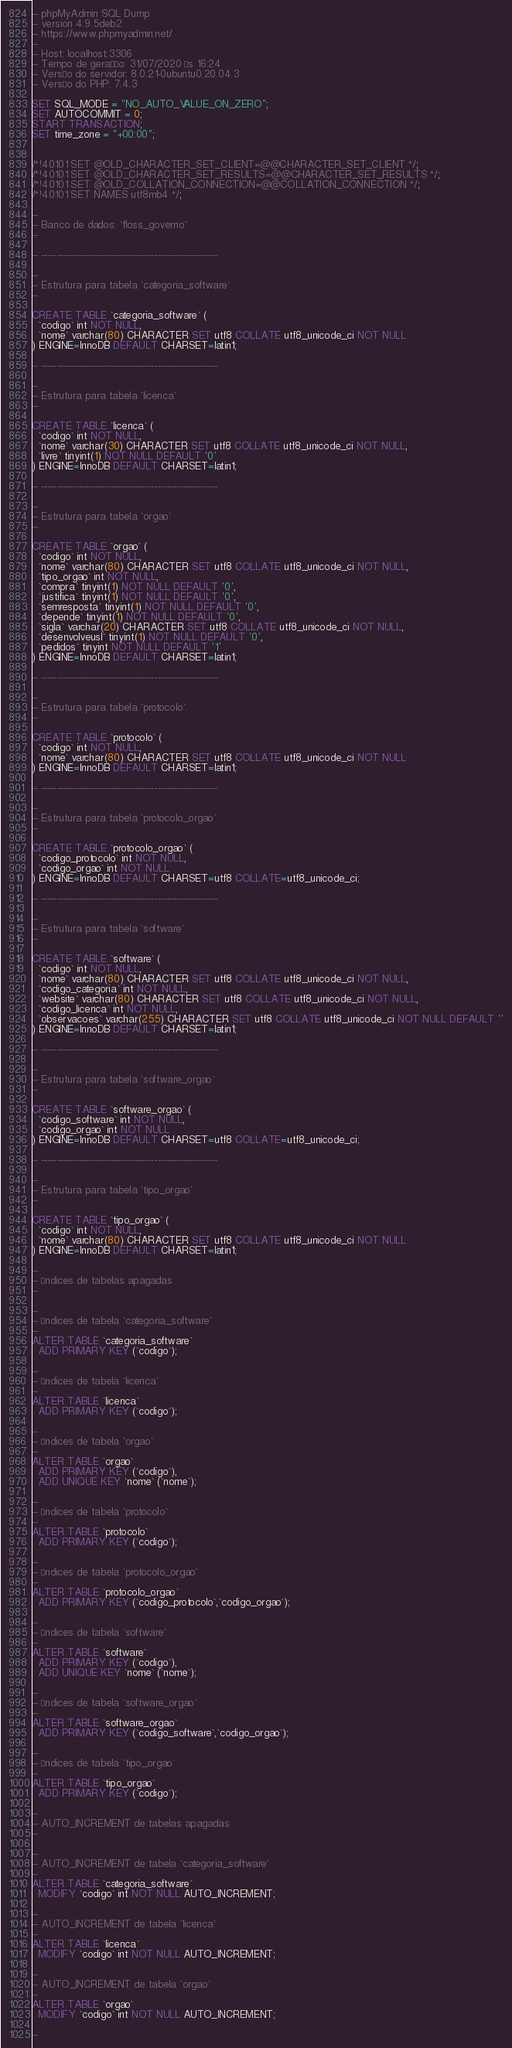Convert code to text. <code><loc_0><loc_0><loc_500><loc_500><_SQL_>-- phpMyAdmin SQL Dump
-- version 4.9.5deb2
-- https://www.phpmyadmin.net/
--
-- Host: localhost:3306
-- Tempo de geração: 31/07/2020 às 16:24
-- Versão do servidor: 8.0.21-0ubuntu0.20.04.3
-- Versão do PHP: 7.4.3

SET SQL_MODE = "NO_AUTO_VALUE_ON_ZERO";
SET AUTOCOMMIT = 0;
START TRANSACTION;
SET time_zone = "+00:00";


/*!40101 SET @OLD_CHARACTER_SET_CLIENT=@@CHARACTER_SET_CLIENT */;
/*!40101 SET @OLD_CHARACTER_SET_RESULTS=@@CHARACTER_SET_RESULTS */;
/*!40101 SET @OLD_COLLATION_CONNECTION=@@COLLATION_CONNECTION */;
/*!40101 SET NAMES utf8mb4 */;

--
-- Banco de dados: `floss_governo`
--

-- --------------------------------------------------------

--
-- Estrutura para tabela `categoria_software`
--

CREATE TABLE `categoria_software` (
  `codigo` int NOT NULL,
  `nome` varchar(80) CHARACTER SET utf8 COLLATE utf8_unicode_ci NOT NULL
) ENGINE=InnoDB DEFAULT CHARSET=latin1;

-- --------------------------------------------------------

--
-- Estrutura para tabela `licenca`
--

CREATE TABLE `licenca` (
  `codigo` int NOT NULL,
  `nome` varchar(30) CHARACTER SET utf8 COLLATE utf8_unicode_ci NOT NULL,
  `livre` tinyint(1) NOT NULL DEFAULT '0'
) ENGINE=InnoDB DEFAULT CHARSET=latin1;

-- --------------------------------------------------------

--
-- Estrutura para tabela `orgao`
--

CREATE TABLE `orgao` (
  `codigo` int NOT NULL,
  `nome` varchar(80) CHARACTER SET utf8 COLLATE utf8_unicode_ci NOT NULL,
  `tipo_orgao` int NOT NULL,
  `compra` tinyint(1) NOT NULL DEFAULT '0',
  `justifica` tinyint(1) NOT NULL DEFAULT '0',
  `semresposta` tinyint(1) NOT NULL DEFAULT '0',
  `depende` tinyint(1) NOT NULL DEFAULT '0',
  `sigla` varchar(20) CHARACTER SET utf8 COLLATE utf8_unicode_ci NOT NULL,
  `desenvolveusl` tinyint(1) NOT NULL DEFAULT '0',
  `pedidos` tinyint NOT NULL DEFAULT '1'
) ENGINE=InnoDB DEFAULT CHARSET=latin1;

-- --------------------------------------------------------

--
-- Estrutura para tabela `protocolo`
--

CREATE TABLE `protocolo` (
  `codigo` int NOT NULL,
  `nome` varchar(80) CHARACTER SET utf8 COLLATE utf8_unicode_ci NOT NULL
) ENGINE=InnoDB DEFAULT CHARSET=latin1;

-- --------------------------------------------------------

--
-- Estrutura para tabela `protocolo_orgao`
--

CREATE TABLE `protocolo_orgao` (
  `codigo_protocolo` int NOT NULL,
  `codigo_orgao` int NOT NULL
) ENGINE=InnoDB DEFAULT CHARSET=utf8 COLLATE=utf8_unicode_ci;

-- --------------------------------------------------------

--
-- Estrutura para tabela `software`
--

CREATE TABLE `software` (
  `codigo` int NOT NULL,
  `nome` varchar(80) CHARACTER SET utf8 COLLATE utf8_unicode_ci NOT NULL,
  `codigo_categoria` int NOT NULL,
  `website` varchar(80) CHARACTER SET utf8 COLLATE utf8_unicode_ci NOT NULL,
  `codigo_licenca` int NOT NULL,
  `observacoes` varchar(255) CHARACTER SET utf8 COLLATE utf8_unicode_ci NOT NULL DEFAULT ''
) ENGINE=InnoDB DEFAULT CHARSET=latin1;

-- --------------------------------------------------------

--
-- Estrutura para tabela `software_orgao`
--

CREATE TABLE `software_orgao` (
  `codigo_software` int NOT NULL,
  `codigo_orgao` int NOT NULL
) ENGINE=InnoDB DEFAULT CHARSET=utf8 COLLATE=utf8_unicode_ci;

-- --------------------------------------------------------

--
-- Estrutura para tabela `tipo_orgao`
--

CREATE TABLE `tipo_orgao` (
  `codigo` int NOT NULL,
  `nome` varchar(80) CHARACTER SET utf8 COLLATE utf8_unicode_ci NOT NULL
) ENGINE=InnoDB DEFAULT CHARSET=latin1;

--
-- Índices de tabelas apagadas
--

--
-- Índices de tabela `categoria_software`
--
ALTER TABLE `categoria_software`
  ADD PRIMARY KEY (`codigo`);

--
-- Índices de tabela `licenca`
--
ALTER TABLE `licenca`
  ADD PRIMARY KEY (`codigo`);

--
-- Índices de tabela `orgao`
--
ALTER TABLE `orgao`
  ADD PRIMARY KEY (`codigo`),
  ADD UNIQUE KEY `nome` (`nome`);

--
-- Índices de tabela `protocolo`
--
ALTER TABLE `protocolo`
  ADD PRIMARY KEY (`codigo`);

--
-- Índices de tabela `protocolo_orgao`
--
ALTER TABLE `protocolo_orgao`
  ADD PRIMARY KEY (`codigo_protocolo`,`codigo_orgao`);

--
-- Índices de tabela `software`
--
ALTER TABLE `software`
  ADD PRIMARY KEY (`codigo`),
  ADD UNIQUE KEY `nome` (`nome`);

--
-- Índices de tabela `software_orgao`
--
ALTER TABLE `software_orgao`
  ADD PRIMARY KEY (`codigo_software`,`codigo_orgao`);

--
-- Índices de tabela `tipo_orgao`
--
ALTER TABLE `tipo_orgao`
  ADD PRIMARY KEY (`codigo`);

--
-- AUTO_INCREMENT de tabelas apagadas
--

--
-- AUTO_INCREMENT de tabela `categoria_software`
--
ALTER TABLE `categoria_software`
  MODIFY `codigo` int NOT NULL AUTO_INCREMENT;

--
-- AUTO_INCREMENT de tabela `licenca`
--
ALTER TABLE `licenca`
  MODIFY `codigo` int NOT NULL AUTO_INCREMENT;

--
-- AUTO_INCREMENT de tabela `orgao`
--
ALTER TABLE `orgao`
  MODIFY `codigo` int NOT NULL AUTO_INCREMENT;

--</code> 